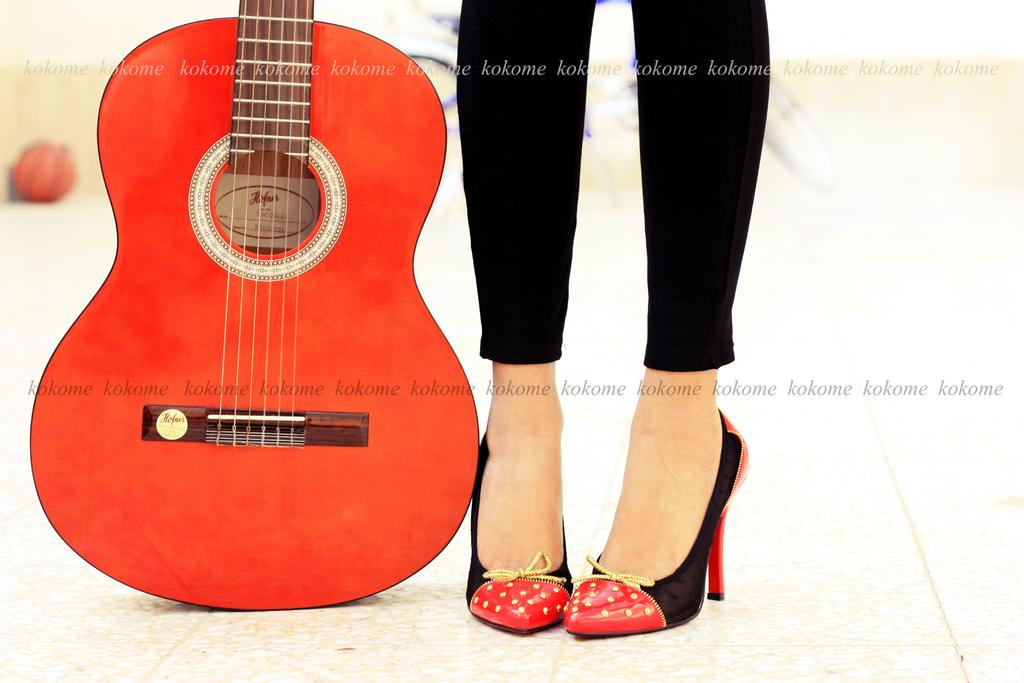What object is located on the left side of the image? There is a red color guitar on the left side of the image. What type of footwear is the girl wearing in the image? The girl is wearing black color shoes in the image. What type of clothing is the girl wearing on her lower body in the image? The girl is wearing trousers in the image. What type of ornament is hanging from the moon in the image? There is no moon or ornament present in the image. How does the girl's death affect the image? There is no mention of death or any negative event in the image, so it does not affect the image. 